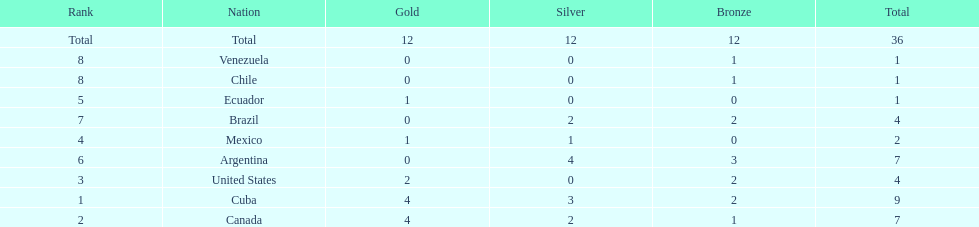Which country won the largest haul of bronze medals? Argentina. 